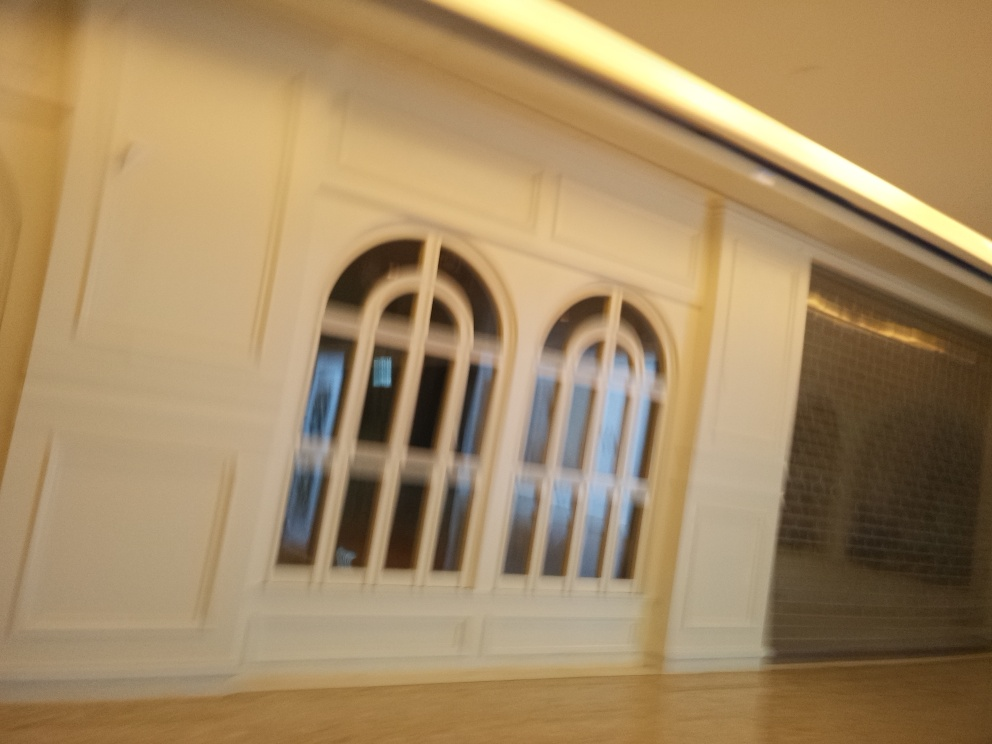Is there blurriness present in the image? Yes, there is noticeable blurriness throughout the image. This can be due to camera motion during the shot or a low shutter speed, which did not freeze the scene, resulting in an image that lacks sharpness and clear definition. 